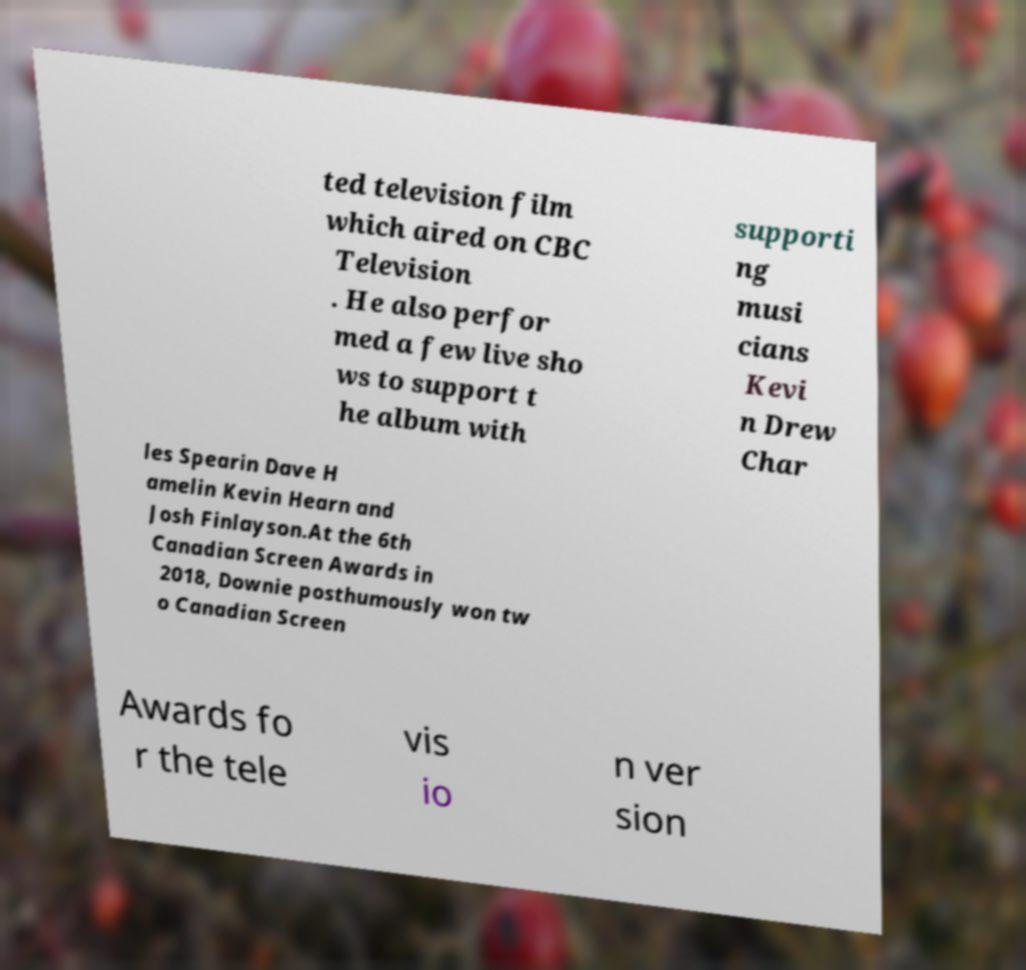Could you assist in decoding the text presented in this image and type it out clearly? ted television film which aired on CBC Television . He also perfor med a few live sho ws to support t he album with supporti ng musi cians Kevi n Drew Char les Spearin Dave H amelin Kevin Hearn and Josh Finlayson.At the 6th Canadian Screen Awards in 2018, Downie posthumously won tw o Canadian Screen Awards fo r the tele vis io n ver sion 